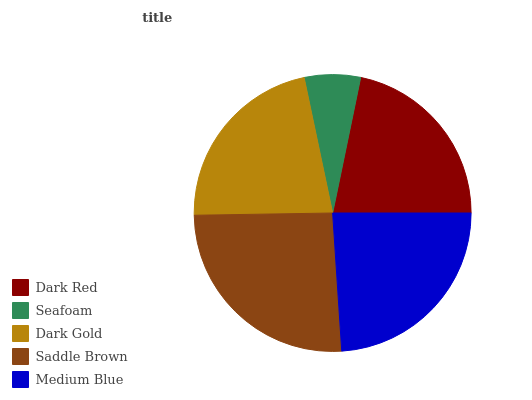Is Seafoam the minimum?
Answer yes or no. Yes. Is Saddle Brown the maximum?
Answer yes or no. Yes. Is Dark Gold the minimum?
Answer yes or no. No. Is Dark Gold the maximum?
Answer yes or no. No. Is Dark Gold greater than Seafoam?
Answer yes or no. Yes. Is Seafoam less than Dark Gold?
Answer yes or no. Yes. Is Seafoam greater than Dark Gold?
Answer yes or no. No. Is Dark Gold less than Seafoam?
Answer yes or no. No. Is Dark Gold the high median?
Answer yes or no. Yes. Is Dark Gold the low median?
Answer yes or no. Yes. Is Seafoam the high median?
Answer yes or no. No. Is Medium Blue the low median?
Answer yes or no. No. 